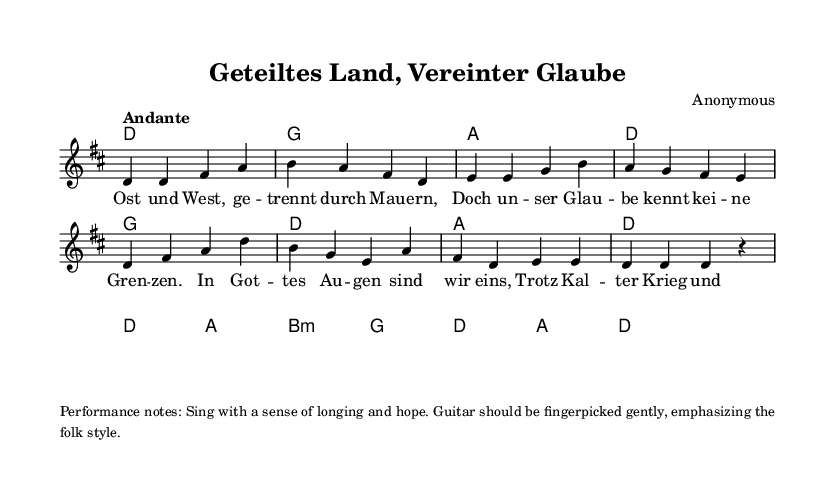What is the key signature of this music? The key signature is determined by the sharps or flats placed at the beginning of the staff. In this case, there are two sharps (F# and C#), which indicates the key of D major.
Answer: D major What is the time signature of this music? The time signature appears at the beginning of the piece and indicates how many beats are in each measure. Here, it is indicated as 4/4, meaning there are four beats in each measure and the quarter note gets one beat.
Answer: 4/4 What is the tempo marking of this piece? The tempo marking, which instructs the performer on the speed of the music, is located near the beginning of the score. It states "Andante," indicating a moderate walking pace.
Answer: Andante How many measures are in the piece? By counting the number of separated units (bars) in the score, we find that there are a total of 8 measures represented in both the melody and harmonies.
Answer: 8 Which instruments should accompany the lead vocal? The score specifies the use of guitar to accompany the lead vocal, as noted in the performance notes produced in the markup section.
Answer: Guitar What theme does the text of the song address? By analyzing the lyrics, the song addresses the themes of unity and faith amidst division, particularly in the context of East and West Germany during Cold War tensions.
Answer: Unity and faith What is the function of the chord symbols in the score? The chord symbols above the staff indicate which chords should be played by the accompanying instrument, providing harmonic support to the melody sung by the lead voice.
Answer: Harmonic support 